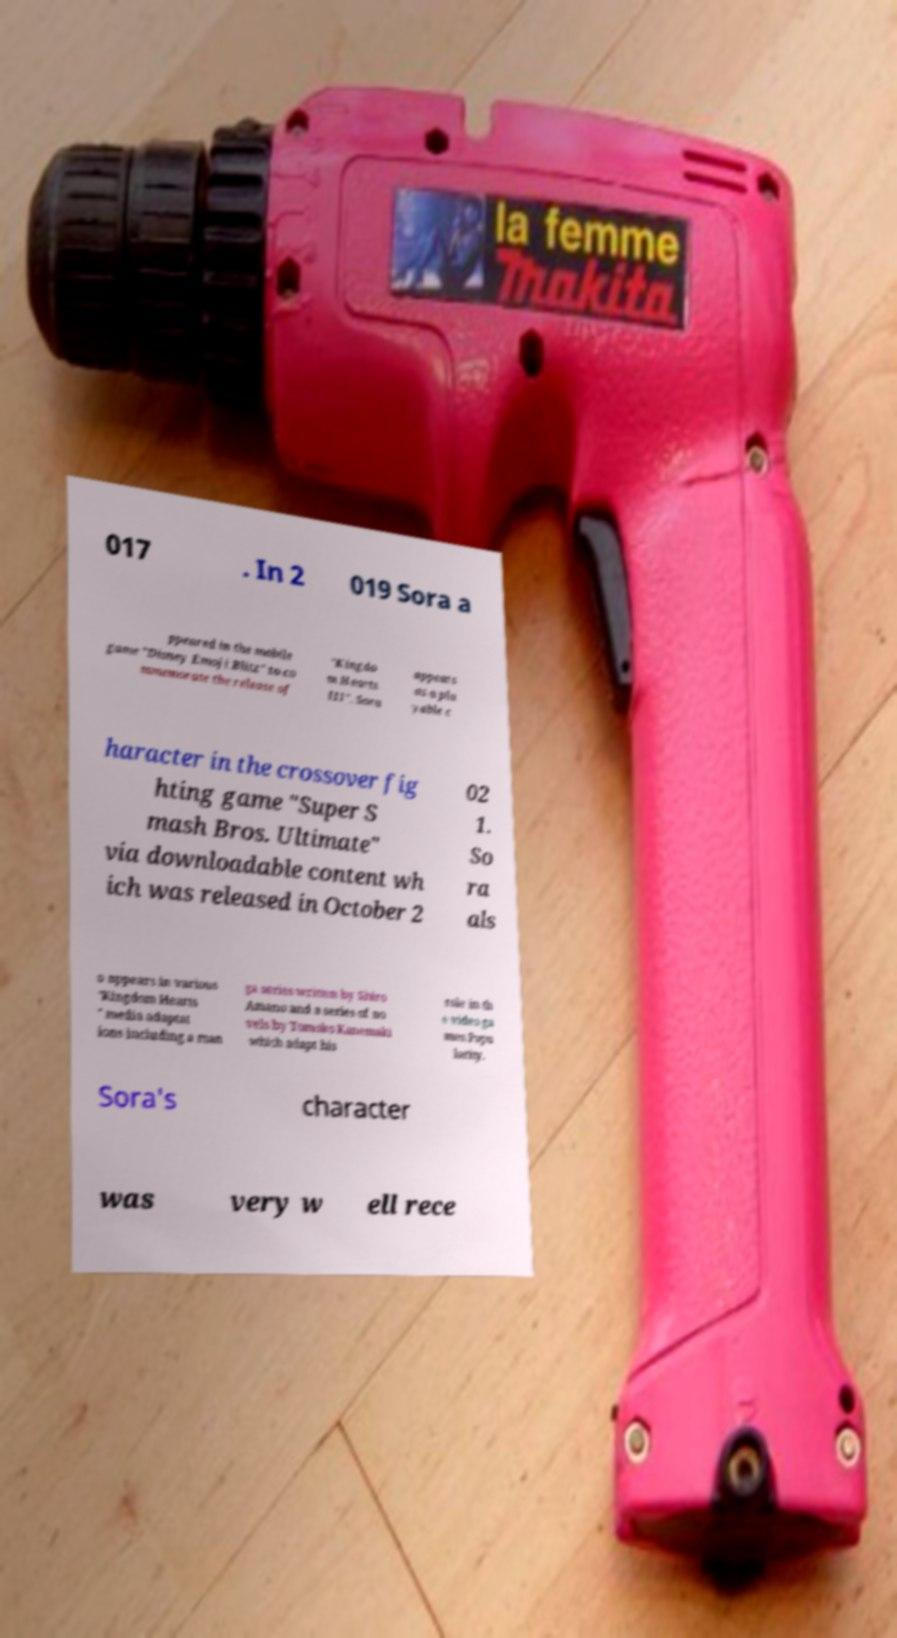Can you read and provide the text displayed in the image?This photo seems to have some interesting text. Can you extract and type it out for me? 017 . In 2 019 Sora a ppeared in the mobile game "Disney Emoji Blitz" to co mmemorate the release of "Kingdo m Hearts III". Sora appears as a pla yable c haracter in the crossover fig hting game "Super S mash Bros. Ultimate" via downloadable content wh ich was released in October 2 02 1. So ra als o appears in various "Kingdom Hearts " media adaptat ions including a man ga series written by Shiro Amano and a series of no vels by Tomoko Kanemaki which adapt his role in th e video ga mes.Popu larity. Sora's character was very w ell rece 